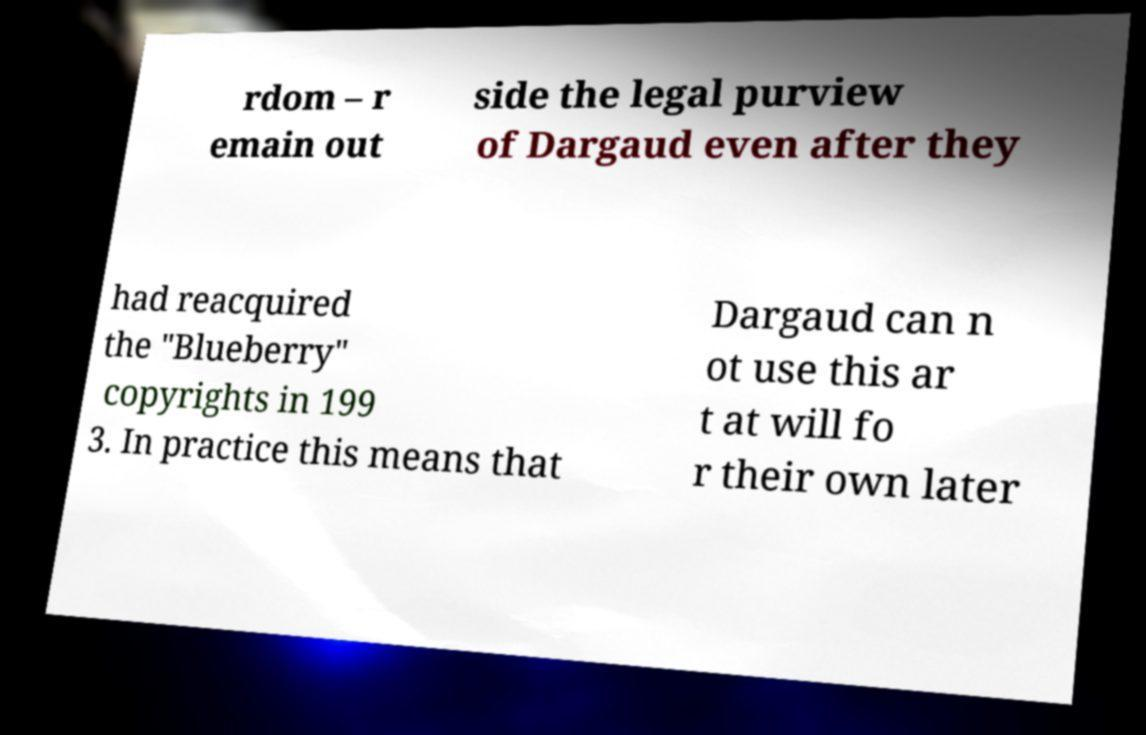Please identify and transcribe the text found in this image. rdom – r emain out side the legal purview of Dargaud even after they had reacquired the "Blueberry" copyrights in 199 3. In practice this means that Dargaud can n ot use this ar t at will fo r their own later 